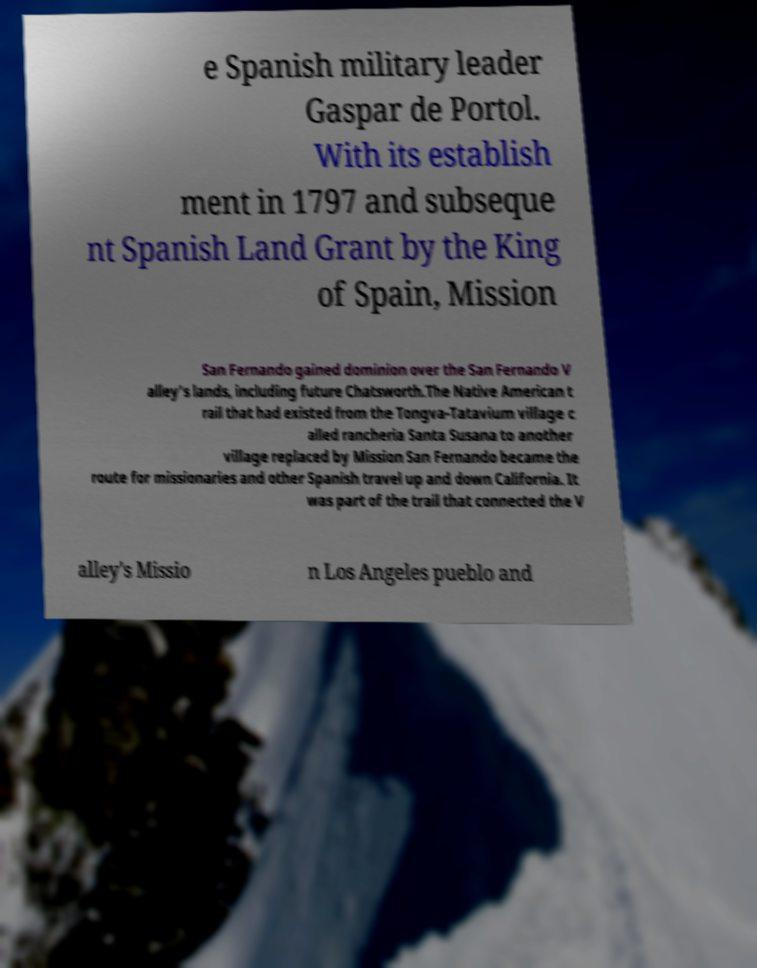What messages or text are displayed in this image? I need them in a readable, typed format. e Spanish military leader Gaspar de Portol. With its establish ment in 1797 and subseque nt Spanish Land Grant by the King of Spain, Mission San Fernando gained dominion over the San Fernando V alley's lands, including future Chatsworth.The Native American t rail that had existed from the Tongva-Tatavium village c alled rancheria Santa Susana to another village replaced by Mission San Fernando became the route for missionaries and other Spanish travel up and down California. It was part of the trail that connected the V alley's Missio n Los Angeles pueblo and 